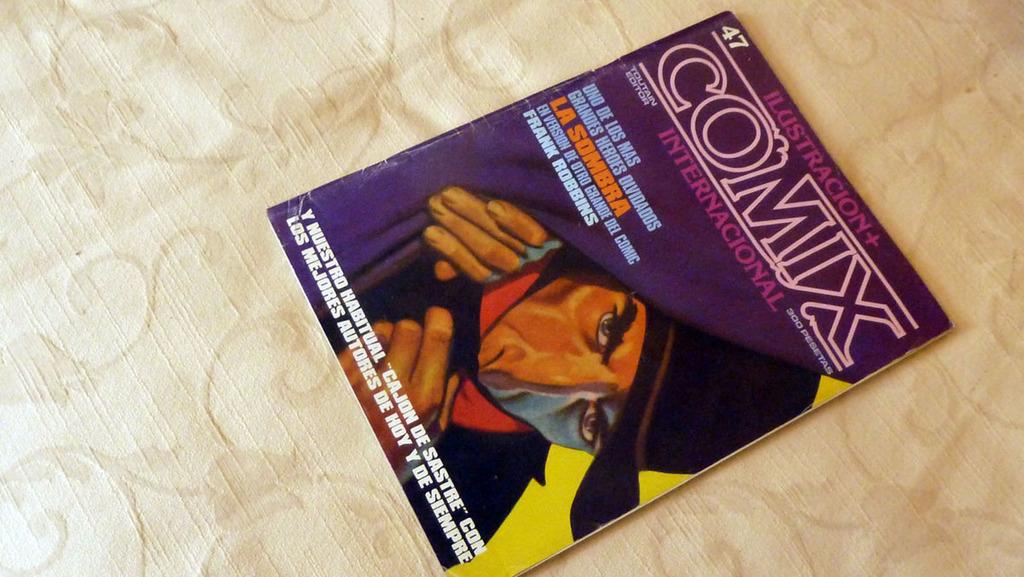<image>
Provide a brief description of the given image. A cover of Comix with a man showed peeking behind a curtain 